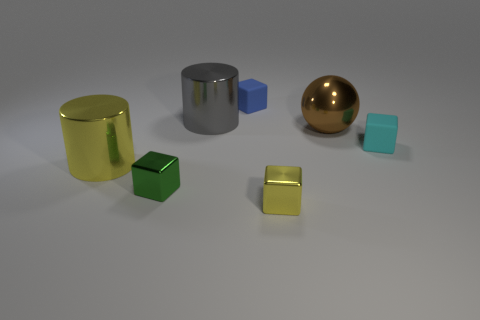Are any tiny blue blocks visible?
Give a very brief answer. Yes. Is there any other thing that has the same material as the blue object?
Your answer should be compact. Yes. Are there any large blue blocks made of the same material as the yellow cube?
Your answer should be very brief. No. What is the material of the green cube that is the same size as the blue matte thing?
Provide a succinct answer. Metal. How many other cyan rubber objects are the same shape as the cyan matte object?
Keep it short and to the point. 0. The blue block that is made of the same material as the tiny cyan block is what size?
Offer a terse response. Small. There is a object that is both to the left of the tiny blue block and behind the cyan matte cube; what material is it made of?
Give a very brief answer. Metal. How many cylinders have the same size as the blue rubber block?
Provide a short and direct response. 0. There is a big gray object that is the same shape as the big yellow shiny thing; what is its material?
Your answer should be very brief. Metal. How many things are big things that are behind the ball or shiny cubes right of the gray metal cylinder?
Ensure brevity in your answer.  2. 